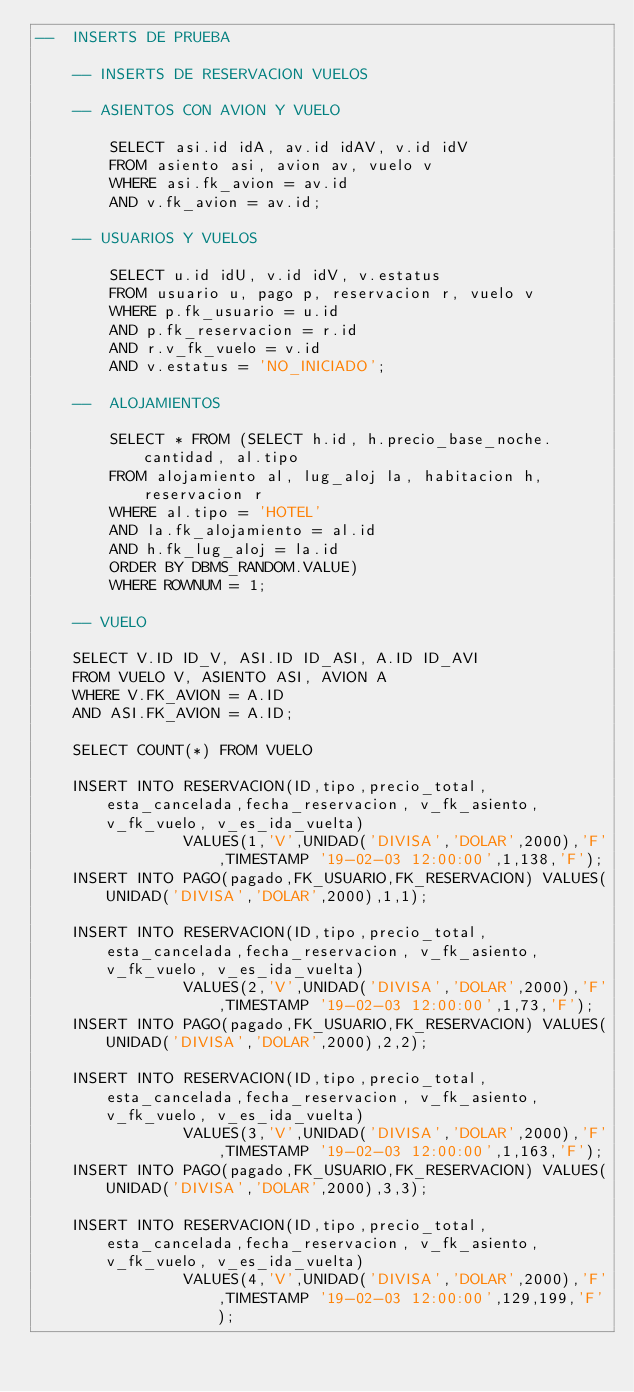<code> <loc_0><loc_0><loc_500><loc_500><_SQL_>--  INSERTS DE PRUEBA

    -- INSERTS DE RESERVACION VUELOS

    -- ASIENTOS CON AVION Y VUELO

        SELECT asi.id idA, av.id idAV, v.id idV
        FROM asiento asi, avion av, vuelo v
        WHERE asi.fk_avion = av.id
        AND v.fk_avion = av.id;

    -- USUARIOS Y VUELOS

        SELECT u.id idU, v.id idV, v.estatus
        FROM usuario u, pago p, reservacion r, vuelo v
        WHERE p.fk_usuario = u.id
        AND p.fk_reservacion = r.id
        AND r.v_fk_vuelo = v.id
        AND v.estatus = 'NO_INICIADO'; 

    --  ALOJAMIENTOS 

        SELECT * FROM (SELECT h.id, h.precio_base_noche.cantidad, al.tipo
        FROM alojamiento al, lug_aloj la, habitacion h, reservacion r
        WHERE al.tipo = 'HOTEL'
        AND la.fk_alojamiento = al.id
        AND h.fk_lug_aloj = la.id
        ORDER BY DBMS_RANDOM.VALUE)
        WHERE ROWNUM = 1;

    -- VUELO

    SELECT V.ID ID_V, ASI.ID ID_ASI, A.ID ID_AVI
    FROM VUELO V, ASIENTO ASI, AVION A
    WHERE V.FK_AVION = A.ID
    AND ASI.FK_AVION = A.ID;

    SELECT COUNT(*) FROM VUELO 

    INSERT INTO RESERVACION(ID,tipo,precio_total,esta_cancelada,fecha_reservacion, v_fk_asiento, v_fk_vuelo, v_es_ida_vuelta)
                VALUES(1,'V',UNIDAD('DIVISA','DOLAR',2000),'F',TIMESTAMP '19-02-03 12:00:00',1,138,'F');
    INSERT INTO PAGO(pagado,FK_USUARIO,FK_RESERVACION) VALUES(UNIDAD('DIVISA','DOLAR',2000),1,1);

    INSERT INTO RESERVACION(ID,tipo,precio_total,esta_cancelada,fecha_reservacion, v_fk_asiento, v_fk_vuelo, v_es_ida_vuelta)
                VALUES(2,'V',UNIDAD('DIVISA','DOLAR',2000),'F',TIMESTAMP '19-02-03 12:00:00',1,73,'F');
    INSERT INTO PAGO(pagado,FK_USUARIO,FK_RESERVACION) VALUES(UNIDAD('DIVISA','DOLAR',2000),2,2);
    
    INSERT INTO RESERVACION(ID,tipo,precio_total,esta_cancelada,fecha_reservacion, v_fk_asiento, v_fk_vuelo, v_es_ida_vuelta)
                VALUES(3,'V',UNIDAD('DIVISA','DOLAR',2000),'F',TIMESTAMP '19-02-03 12:00:00',1,163,'F');
    INSERT INTO PAGO(pagado,FK_USUARIO,FK_RESERVACION) VALUES(UNIDAD('DIVISA','DOLAR',2000),3,3);

    INSERT INTO RESERVACION(ID,tipo,precio_total,esta_cancelada,fecha_reservacion, v_fk_asiento, v_fk_vuelo, v_es_ida_vuelta)
                VALUES(4,'V',UNIDAD('DIVISA','DOLAR',2000),'F',TIMESTAMP '19-02-03 12:00:00',129,199,'F');</code> 